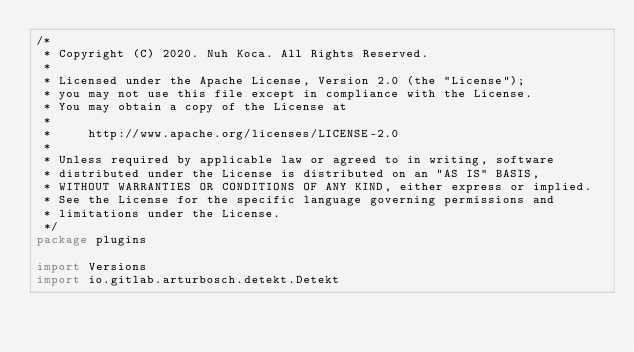Convert code to text. <code><loc_0><loc_0><loc_500><loc_500><_Kotlin_>/*
 * Copyright (C) 2020. Nuh Koca. All Rights Reserved.
 *
 * Licensed under the Apache License, Version 2.0 (the "License");
 * you may not use this file except in compliance with the License.
 * You may obtain a copy of the License at
 *
 *     http://www.apache.org/licenses/LICENSE-2.0
 *
 * Unless required by applicable law or agreed to in writing, software
 * distributed under the License is distributed on an "AS IS" BASIS,
 * WITHOUT WARRANTIES OR CONDITIONS OF ANY KIND, either express or implied.
 * See the License for the specific language governing permissions and
 * limitations under the License.
 */
package plugins

import Versions
import io.gitlab.arturbosch.detekt.Detekt</code> 